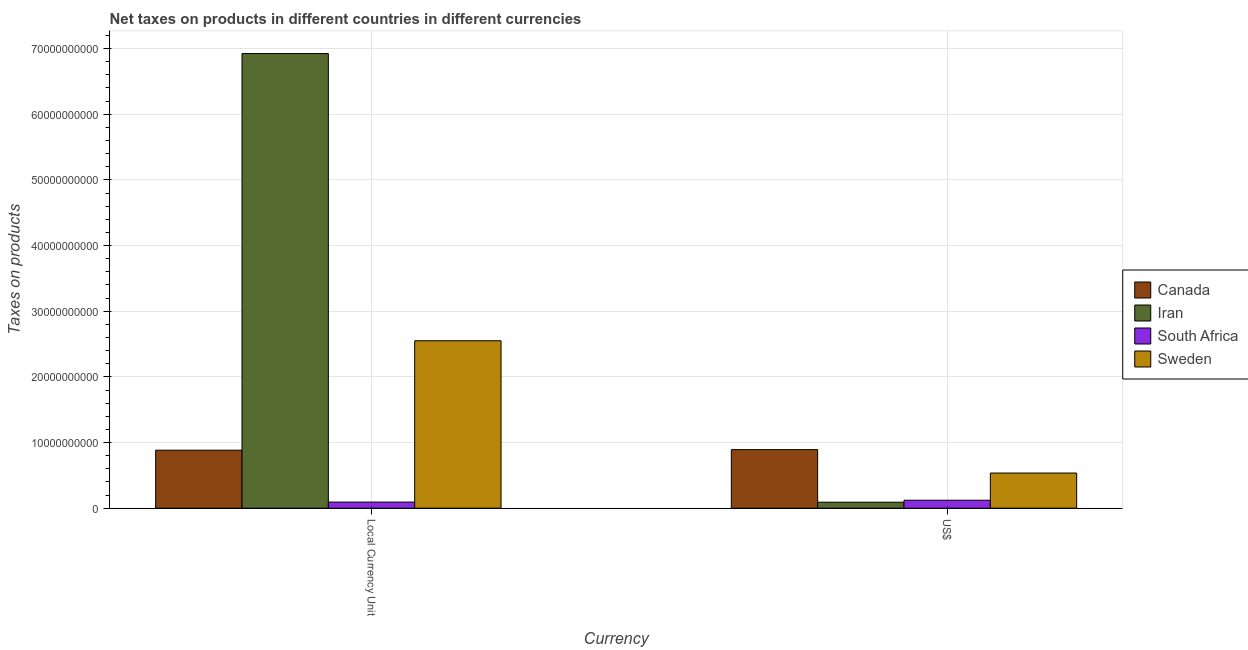Are the number of bars per tick equal to the number of legend labels?
Provide a short and direct response. Yes. Are the number of bars on each tick of the X-axis equal?
Your answer should be very brief. Yes. How many bars are there on the 2nd tick from the left?
Your answer should be very brief. 4. What is the label of the 2nd group of bars from the left?
Give a very brief answer. US$. What is the net taxes in constant 2005 us$ in Canada?
Your response must be concise. 8.83e+09. Across all countries, what is the maximum net taxes in us$?
Provide a succinct answer. 8.92e+09. Across all countries, what is the minimum net taxes in constant 2005 us$?
Offer a terse response. 9.32e+08. In which country was the net taxes in us$ maximum?
Provide a short and direct response. Canada. In which country was the net taxes in constant 2005 us$ minimum?
Ensure brevity in your answer.  South Africa. What is the total net taxes in us$ in the graph?
Keep it short and to the point. 1.64e+1. What is the difference between the net taxes in constant 2005 us$ in South Africa and that in Canada?
Offer a terse response. -7.90e+09. What is the difference between the net taxes in us$ in Sweden and the net taxes in constant 2005 us$ in Iran?
Provide a succinct answer. -6.39e+1. What is the average net taxes in constant 2005 us$ per country?
Keep it short and to the point. 2.61e+1. What is the difference between the net taxes in us$ and net taxes in constant 2005 us$ in Canada?
Provide a short and direct response. 9.01e+07. What is the ratio of the net taxes in constant 2005 us$ in South Africa to that in Iran?
Offer a terse response. 0.01. In how many countries, is the net taxes in constant 2005 us$ greater than the average net taxes in constant 2005 us$ taken over all countries?
Offer a terse response. 1. What does the 4th bar from the left in US$ represents?
Provide a succinct answer. Sweden. What does the 2nd bar from the right in US$ represents?
Ensure brevity in your answer.  South Africa. How many bars are there?
Provide a short and direct response. 8. How many countries are there in the graph?
Your response must be concise. 4. What is the difference between two consecutive major ticks on the Y-axis?
Offer a terse response. 1.00e+1. Are the values on the major ticks of Y-axis written in scientific E-notation?
Your answer should be compact. No. Does the graph contain any zero values?
Your answer should be compact. No. How many legend labels are there?
Provide a short and direct response. 4. What is the title of the graph?
Ensure brevity in your answer.  Net taxes on products in different countries in different currencies. What is the label or title of the X-axis?
Provide a succinct answer. Currency. What is the label or title of the Y-axis?
Offer a very short reply. Taxes on products. What is the Taxes on products of Canada in Local Currency Unit?
Offer a very short reply. 8.83e+09. What is the Taxes on products in Iran in Local Currency Unit?
Give a very brief answer. 6.92e+1. What is the Taxes on products of South Africa in Local Currency Unit?
Your answer should be very brief. 9.32e+08. What is the Taxes on products of Sweden in Local Currency Unit?
Provide a succinct answer. 2.55e+1. What is the Taxes on products of Canada in US$?
Offer a very short reply. 8.92e+09. What is the Taxes on products in Iran in US$?
Offer a very short reply. 9.14e+08. What is the Taxes on products in South Africa in US$?
Offer a very short reply. 1.21e+09. What is the Taxes on products in Sweden in US$?
Offer a terse response. 5.35e+09. Across all Currency, what is the maximum Taxes on products of Canada?
Give a very brief answer. 8.92e+09. Across all Currency, what is the maximum Taxes on products in Iran?
Ensure brevity in your answer.  6.92e+1. Across all Currency, what is the maximum Taxes on products in South Africa?
Keep it short and to the point. 1.21e+09. Across all Currency, what is the maximum Taxes on products in Sweden?
Your response must be concise. 2.55e+1. Across all Currency, what is the minimum Taxes on products of Canada?
Offer a terse response. 8.83e+09. Across all Currency, what is the minimum Taxes on products of Iran?
Your response must be concise. 9.14e+08. Across all Currency, what is the minimum Taxes on products in South Africa?
Ensure brevity in your answer.  9.32e+08. Across all Currency, what is the minimum Taxes on products in Sweden?
Offer a very short reply. 5.35e+09. What is the total Taxes on products of Canada in the graph?
Offer a terse response. 1.78e+1. What is the total Taxes on products of Iran in the graph?
Offer a terse response. 7.02e+1. What is the total Taxes on products in South Africa in the graph?
Give a very brief answer. 2.14e+09. What is the total Taxes on products of Sweden in the graph?
Your answer should be compact. 3.09e+1. What is the difference between the Taxes on products of Canada in Local Currency Unit and that in US$?
Provide a short and direct response. -9.01e+07. What is the difference between the Taxes on products of Iran in Local Currency Unit and that in US$?
Provide a succinct answer. 6.83e+1. What is the difference between the Taxes on products of South Africa in Local Currency Unit and that in US$?
Your answer should be very brief. -2.80e+08. What is the difference between the Taxes on products of Sweden in Local Currency Unit and that in US$?
Make the answer very short. 2.01e+1. What is the difference between the Taxes on products in Canada in Local Currency Unit and the Taxes on products in Iran in US$?
Your response must be concise. 7.92e+09. What is the difference between the Taxes on products of Canada in Local Currency Unit and the Taxes on products of South Africa in US$?
Give a very brief answer. 7.62e+09. What is the difference between the Taxes on products of Canada in Local Currency Unit and the Taxes on products of Sweden in US$?
Your answer should be compact. 3.48e+09. What is the difference between the Taxes on products in Iran in Local Currency Unit and the Taxes on products in South Africa in US$?
Offer a very short reply. 6.80e+1. What is the difference between the Taxes on products in Iran in Local Currency Unit and the Taxes on products in Sweden in US$?
Give a very brief answer. 6.39e+1. What is the difference between the Taxes on products in South Africa in Local Currency Unit and the Taxes on products in Sweden in US$?
Provide a succinct answer. -4.42e+09. What is the average Taxes on products of Canada per Currency?
Make the answer very short. 8.88e+09. What is the average Taxes on products of Iran per Currency?
Provide a succinct answer. 3.51e+1. What is the average Taxes on products of South Africa per Currency?
Give a very brief answer. 1.07e+09. What is the average Taxes on products in Sweden per Currency?
Provide a short and direct response. 1.54e+1. What is the difference between the Taxes on products of Canada and Taxes on products of Iran in Local Currency Unit?
Offer a very short reply. -6.04e+1. What is the difference between the Taxes on products in Canada and Taxes on products in South Africa in Local Currency Unit?
Give a very brief answer. 7.90e+09. What is the difference between the Taxes on products of Canada and Taxes on products of Sweden in Local Currency Unit?
Ensure brevity in your answer.  -1.67e+1. What is the difference between the Taxes on products in Iran and Taxes on products in South Africa in Local Currency Unit?
Your answer should be compact. 6.83e+1. What is the difference between the Taxes on products of Iran and Taxes on products of Sweden in Local Currency Unit?
Offer a terse response. 4.37e+1. What is the difference between the Taxes on products in South Africa and Taxes on products in Sweden in Local Currency Unit?
Ensure brevity in your answer.  -2.46e+1. What is the difference between the Taxes on products in Canada and Taxes on products in Iran in US$?
Provide a short and direct response. 8.01e+09. What is the difference between the Taxes on products in Canada and Taxes on products in South Africa in US$?
Keep it short and to the point. 7.71e+09. What is the difference between the Taxes on products in Canada and Taxes on products in Sweden in US$?
Your answer should be very brief. 3.57e+09. What is the difference between the Taxes on products in Iran and Taxes on products in South Africa in US$?
Offer a very short reply. -2.98e+08. What is the difference between the Taxes on products in Iran and Taxes on products in Sweden in US$?
Give a very brief answer. -4.44e+09. What is the difference between the Taxes on products in South Africa and Taxes on products in Sweden in US$?
Make the answer very short. -4.14e+09. What is the ratio of the Taxes on products of Iran in Local Currency Unit to that in US$?
Offer a very short reply. 75.75. What is the ratio of the Taxes on products in South Africa in Local Currency Unit to that in US$?
Your response must be concise. 0.77. What is the ratio of the Taxes on products of Sweden in Local Currency Unit to that in US$?
Ensure brevity in your answer.  4.76. What is the difference between the highest and the second highest Taxes on products of Canada?
Provide a succinct answer. 9.01e+07. What is the difference between the highest and the second highest Taxes on products of Iran?
Provide a succinct answer. 6.83e+1. What is the difference between the highest and the second highest Taxes on products of South Africa?
Offer a very short reply. 2.80e+08. What is the difference between the highest and the second highest Taxes on products of Sweden?
Your answer should be very brief. 2.01e+1. What is the difference between the highest and the lowest Taxes on products in Canada?
Ensure brevity in your answer.  9.01e+07. What is the difference between the highest and the lowest Taxes on products in Iran?
Offer a terse response. 6.83e+1. What is the difference between the highest and the lowest Taxes on products of South Africa?
Provide a short and direct response. 2.80e+08. What is the difference between the highest and the lowest Taxes on products in Sweden?
Provide a short and direct response. 2.01e+1. 